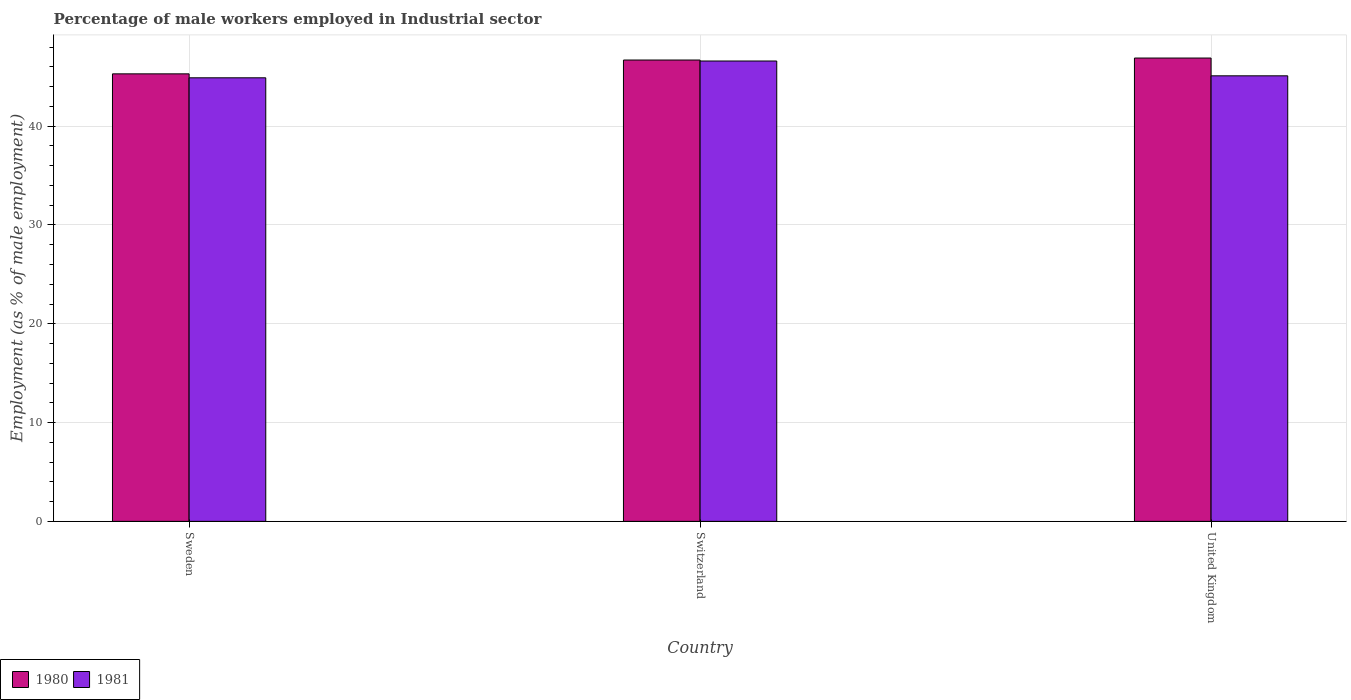How many different coloured bars are there?
Offer a very short reply. 2. How many bars are there on the 3rd tick from the left?
Provide a succinct answer. 2. What is the percentage of male workers employed in Industrial sector in 1980 in Switzerland?
Offer a very short reply. 46.7. Across all countries, what is the maximum percentage of male workers employed in Industrial sector in 1980?
Offer a very short reply. 46.9. Across all countries, what is the minimum percentage of male workers employed in Industrial sector in 1980?
Provide a short and direct response. 45.3. In which country was the percentage of male workers employed in Industrial sector in 1981 maximum?
Provide a short and direct response. Switzerland. In which country was the percentage of male workers employed in Industrial sector in 1980 minimum?
Offer a terse response. Sweden. What is the total percentage of male workers employed in Industrial sector in 1980 in the graph?
Your answer should be compact. 138.9. What is the difference between the percentage of male workers employed in Industrial sector in 1981 in Sweden and that in Switzerland?
Ensure brevity in your answer.  -1.7. What is the difference between the percentage of male workers employed in Industrial sector in 1981 in Sweden and the percentage of male workers employed in Industrial sector in 1980 in Switzerland?
Keep it short and to the point. -1.8. What is the average percentage of male workers employed in Industrial sector in 1980 per country?
Provide a short and direct response. 46.3. What is the difference between the percentage of male workers employed in Industrial sector of/in 1981 and percentage of male workers employed in Industrial sector of/in 1980 in Sweden?
Make the answer very short. -0.4. What is the ratio of the percentage of male workers employed in Industrial sector in 1981 in Sweden to that in Switzerland?
Ensure brevity in your answer.  0.96. Is the percentage of male workers employed in Industrial sector in 1980 in Sweden less than that in Switzerland?
Your answer should be compact. Yes. Is the difference between the percentage of male workers employed in Industrial sector in 1981 in Sweden and United Kingdom greater than the difference between the percentage of male workers employed in Industrial sector in 1980 in Sweden and United Kingdom?
Make the answer very short. Yes. What is the difference between the highest and the second highest percentage of male workers employed in Industrial sector in 1981?
Your answer should be very brief. -0.2. What is the difference between the highest and the lowest percentage of male workers employed in Industrial sector in 1980?
Offer a terse response. 1.6. What does the 1st bar from the left in United Kingdom represents?
Make the answer very short. 1980. What does the 2nd bar from the right in Sweden represents?
Ensure brevity in your answer.  1980. How many bars are there?
Give a very brief answer. 6. How many countries are there in the graph?
Your response must be concise. 3. What is the difference between two consecutive major ticks on the Y-axis?
Keep it short and to the point. 10. Are the values on the major ticks of Y-axis written in scientific E-notation?
Give a very brief answer. No. Does the graph contain any zero values?
Offer a terse response. No. Does the graph contain grids?
Provide a short and direct response. Yes. Where does the legend appear in the graph?
Make the answer very short. Bottom left. What is the title of the graph?
Keep it short and to the point. Percentage of male workers employed in Industrial sector. What is the label or title of the Y-axis?
Ensure brevity in your answer.  Employment (as % of male employment). What is the Employment (as % of male employment) in 1980 in Sweden?
Provide a succinct answer. 45.3. What is the Employment (as % of male employment) of 1981 in Sweden?
Keep it short and to the point. 44.9. What is the Employment (as % of male employment) in 1980 in Switzerland?
Your response must be concise. 46.7. What is the Employment (as % of male employment) in 1981 in Switzerland?
Offer a terse response. 46.6. What is the Employment (as % of male employment) of 1980 in United Kingdom?
Provide a succinct answer. 46.9. What is the Employment (as % of male employment) of 1981 in United Kingdom?
Offer a terse response. 45.1. Across all countries, what is the maximum Employment (as % of male employment) of 1980?
Ensure brevity in your answer.  46.9. Across all countries, what is the maximum Employment (as % of male employment) in 1981?
Ensure brevity in your answer.  46.6. Across all countries, what is the minimum Employment (as % of male employment) in 1980?
Keep it short and to the point. 45.3. Across all countries, what is the minimum Employment (as % of male employment) of 1981?
Provide a succinct answer. 44.9. What is the total Employment (as % of male employment) of 1980 in the graph?
Offer a very short reply. 138.9. What is the total Employment (as % of male employment) in 1981 in the graph?
Make the answer very short. 136.6. What is the difference between the Employment (as % of male employment) of 1980 in Sweden and that in Switzerland?
Give a very brief answer. -1.4. What is the difference between the Employment (as % of male employment) of 1981 in Sweden and that in United Kingdom?
Your answer should be compact. -0.2. What is the difference between the Employment (as % of male employment) of 1981 in Switzerland and that in United Kingdom?
Provide a succinct answer. 1.5. What is the difference between the Employment (as % of male employment) of 1980 in Sweden and the Employment (as % of male employment) of 1981 in Switzerland?
Provide a succinct answer. -1.3. What is the average Employment (as % of male employment) of 1980 per country?
Give a very brief answer. 46.3. What is the average Employment (as % of male employment) of 1981 per country?
Provide a short and direct response. 45.53. What is the difference between the Employment (as % of male employment) of 1980 and Employment (as % of male employment) of 1981 in Sweden?
Ensure brevity in your answer.  0.4. What is the difference between the Employment (as % of male employment) of 1980 and Employment (as % of male employment) of 1981 in United Kingdom?
Your answer should be compact. 1.8. What is the ratio of the Employment (as % of male employment) in 1981 in Sweden to that in Switzerland?
Give a very brief answer. 0.96. What is the ratio of the Employment (as % of male employment) in 1980 in Sweden to that in United Kingdom?
Give a very brief answer. 0.97. What is the ratio of the Employment (as % of male employment) of 1981 in Sweden to that in United Kingdom?
Ensure brevity in your answer.  1. What is the difference between the highest and the lowest Employment (as % of male employment) of 1980?
Your answer should be very brief. 1.6. What is the difference between the highest and the lowest Employment (as % of male employment) in 1981?
Give a very brief answer. 1.7. 